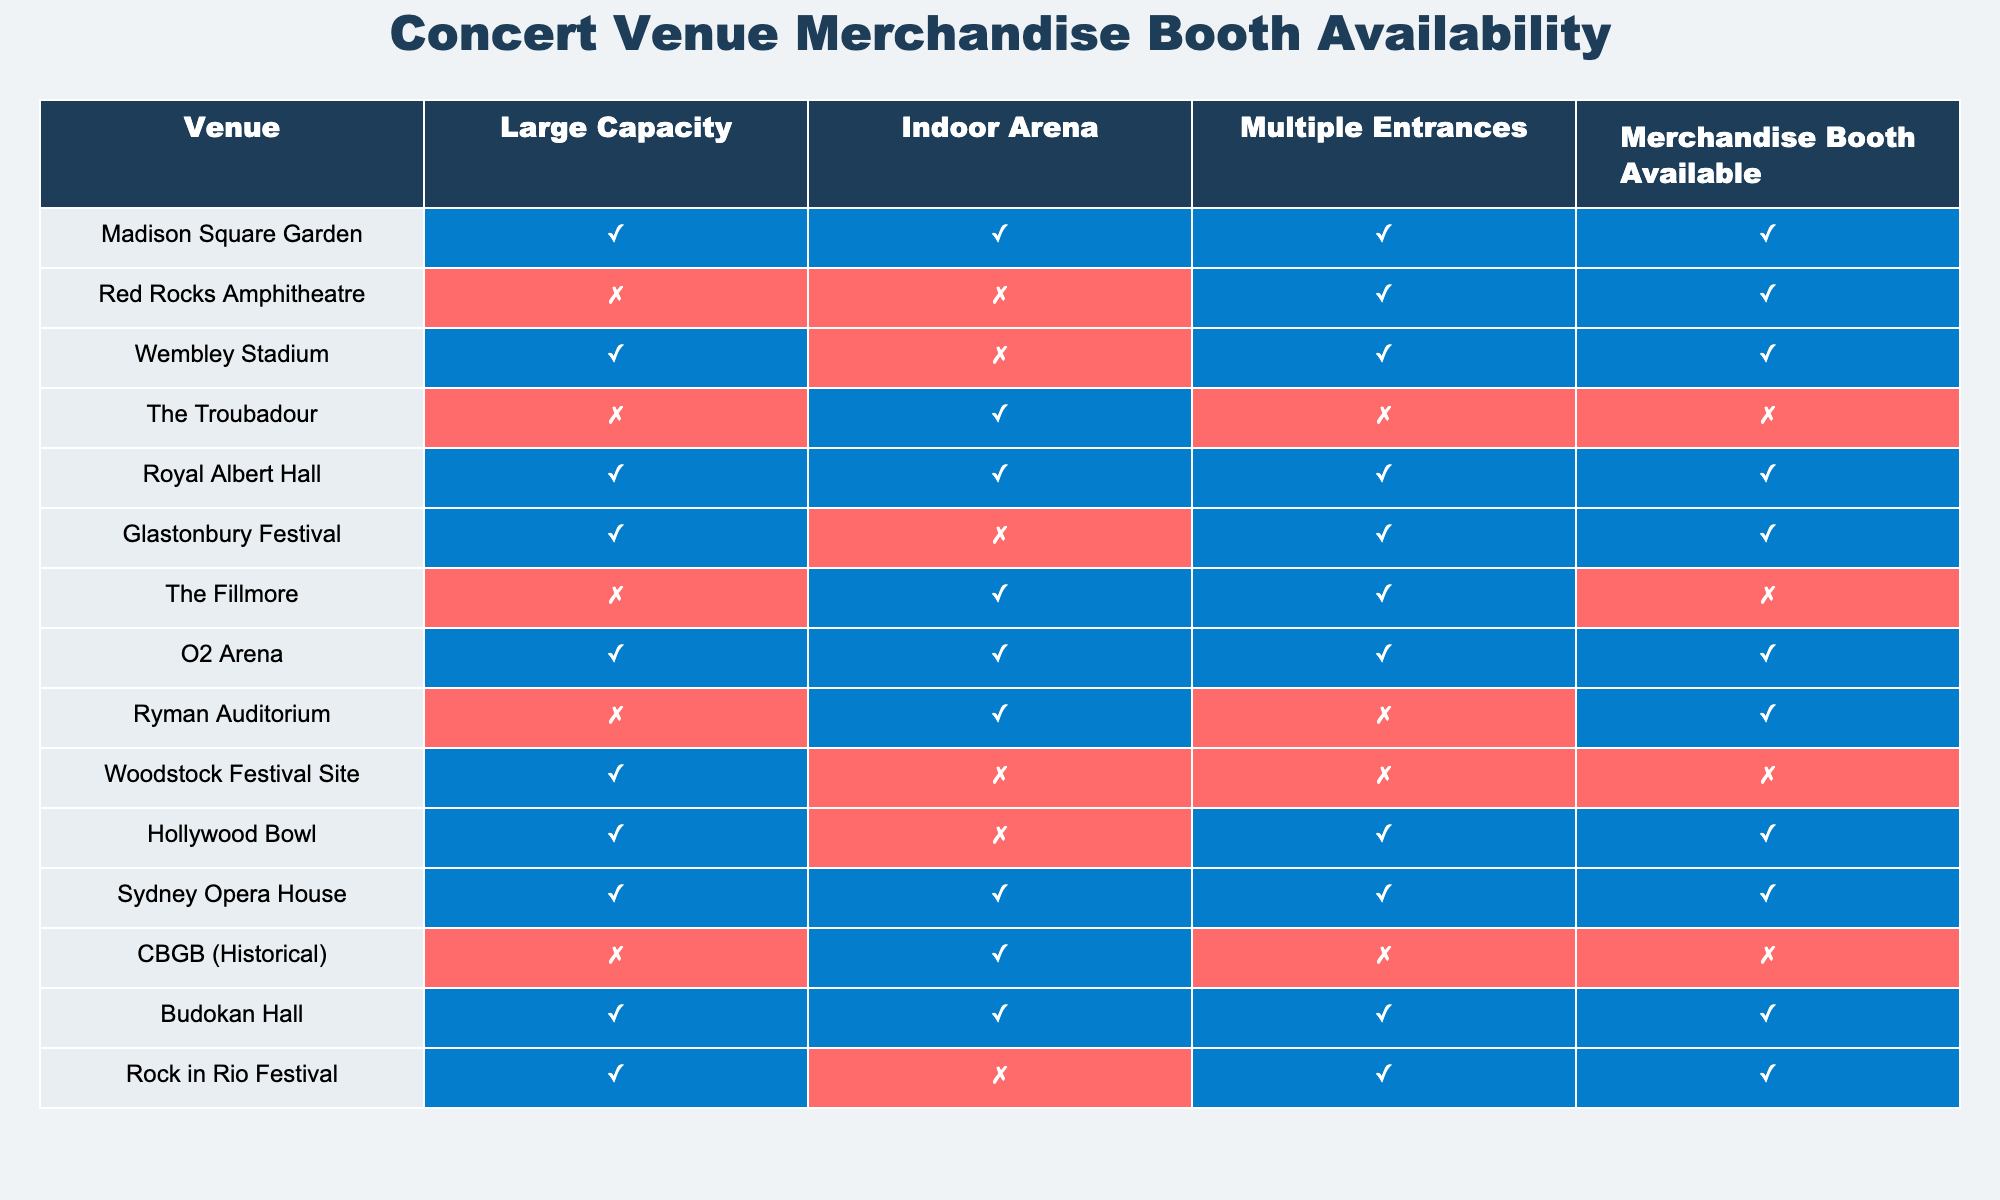What percentage of venues have a merchandise booth available? There are 15 venues listed. The venues with a merchandise booth available are: Madison Square Garden, Red Rocks Amphitheatre, Wembley Stadium, Royal Albert Hall, Glastonbury Festival, O2 Arena, Ryman Auditorium, Hollywood Bowl, Budokan Hall, and Rock in Rio Festival. That's 10 out of 15 venues. The percentage is (10 / 15) * 100 = 66.67%.
Answer: 66.67% Which venue has the largest capacity and also has a merchandise booth available? The venues that are labeled with large capacity and have a merchandise booth available are: Madison Square Garden, Wembley Stadium, Royal Albert Hall, O2 Arena, Budokan Hall, and Rock in Rio Festival. The venue with the largest capacity among these is Wembley Stadium.
Answer: Wembley Stadium Is the Hollywood Bowl an indoor arena? The table indicates that Hollywood Bowl is marked as “True” under the Indoor Arena column, meaning it is an indoor arena.
Answer: Yes Do venues with multiple entrances always have a merchandise booth? From the table, The Fillmore and The Troubadour both have multiple entrances (marked as True) but only The Fillmore has a merchandise booth available (marked as False), while The Troubadour does not have a merchandise booth available (marked as False). This shows that having multiple entrances does not guarantee a merchandise booth.
Answer: No How many venues have a merchandise booth but do not have multiple entrances? The venues that have a merchandise booth available but do not have multiple entrances are: The Troubadour, Woodstock Festival Site, and Ryman Auditorium. This gives a total of 3 venues.
Answer: 3 